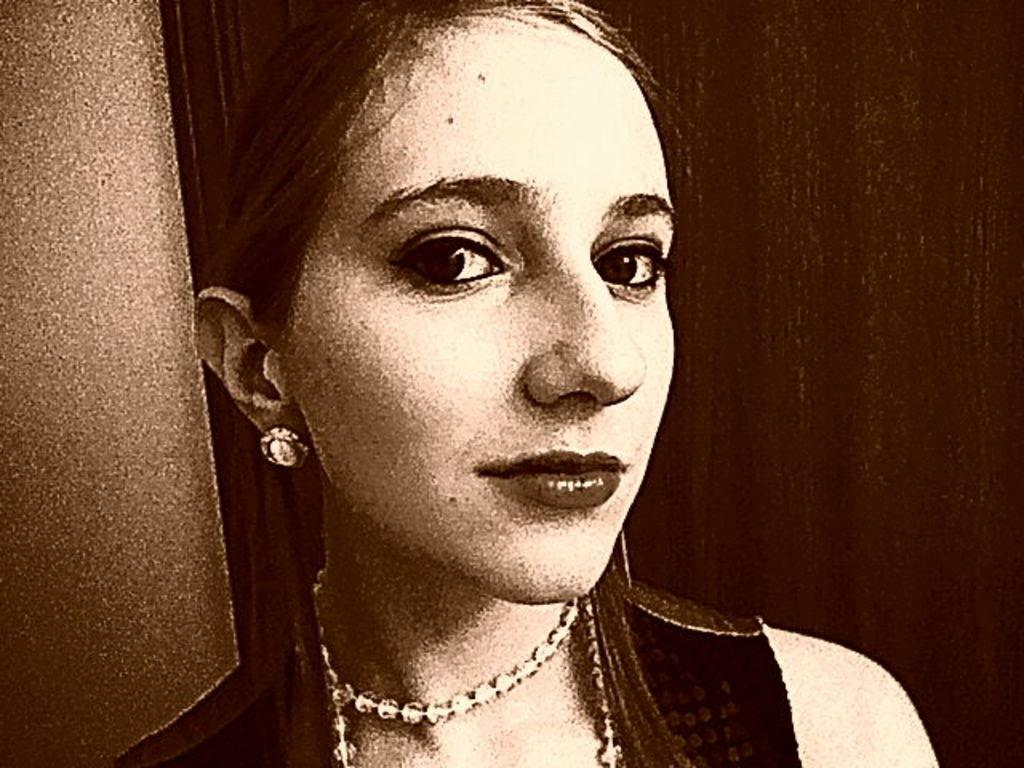Who is the main subject in the image? There is a woman in the center of the image. What type of glue is the woman using in the image? There is no glue present in the image, and the woman is not using any glue. What type of veil is the woman wearing in the image? There is no veil present in the image, and the woman is not wearing any veil. 